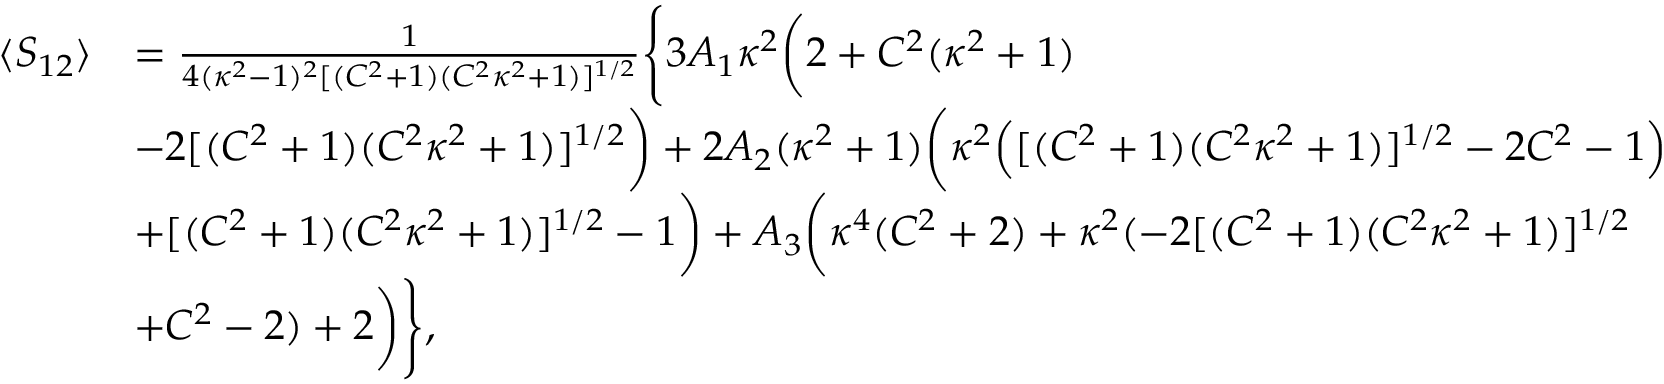Convert formula to latex. <formula><loc_0><loc_0><loc_500><loc_500>\begin{array} { r l } { \langle S _ { 1 2 } \rangle } & { = \frac { 1 } { 4 ( \kappa ^ { 2 } - 1 ) ^ { 2 } [ ( C ^ { 2 } + 1 ) ( C ^ { 2 } \kappa ^ { 2 } + 1 ) ] ^ { 1 / 2 } } \left \{ 3 A _ { 1 } \kappa ^ { 2 } \left ( 2 + C ^ { 2 } ( \kappa ^ { 2 } + 1 ) } \\ & { - 2 [ ( C ^ { 2 } + 1 ) ( C ^ { 2 } \kappa ^ { 2 } + 1 ) ] ^ { 1 / 2 } \right ) + 2 A _ { 2 } ( \kappa ^ { 2 } + 1 ) \left ( \kappa ^ { 2 } \left ( [ ( C ^ { 2 } + 1 ) ( C ^ { 2 } \kappa ^ { 2 } + 1 ) ] ^ { 1 / 2 } - 2 C ^ { 2 } - 1 \right ) } \\ & { + [ ( C ^ { 2 } + 1 ) ( C ^ { 2 } \kappa ^ { 2 } + 1 ) ] ^ { 1 / 2 } - 1 \right ) + A _ { 3 } \left ( \kappa ^ { 4 } ( C ^ { 2 } + 2 ) + \kappa ^ { 2 } ( - 2 [ ( C ^ { 2 } + 1 ) ( C ^ { 2 } \kappa ^ { 2 } + 1 ) ] ^ { 1 / 2 } } \\ & { + C ^ { 2 } - 2 ) + 2 \right ) \right \} , } \end{array}</formula> 